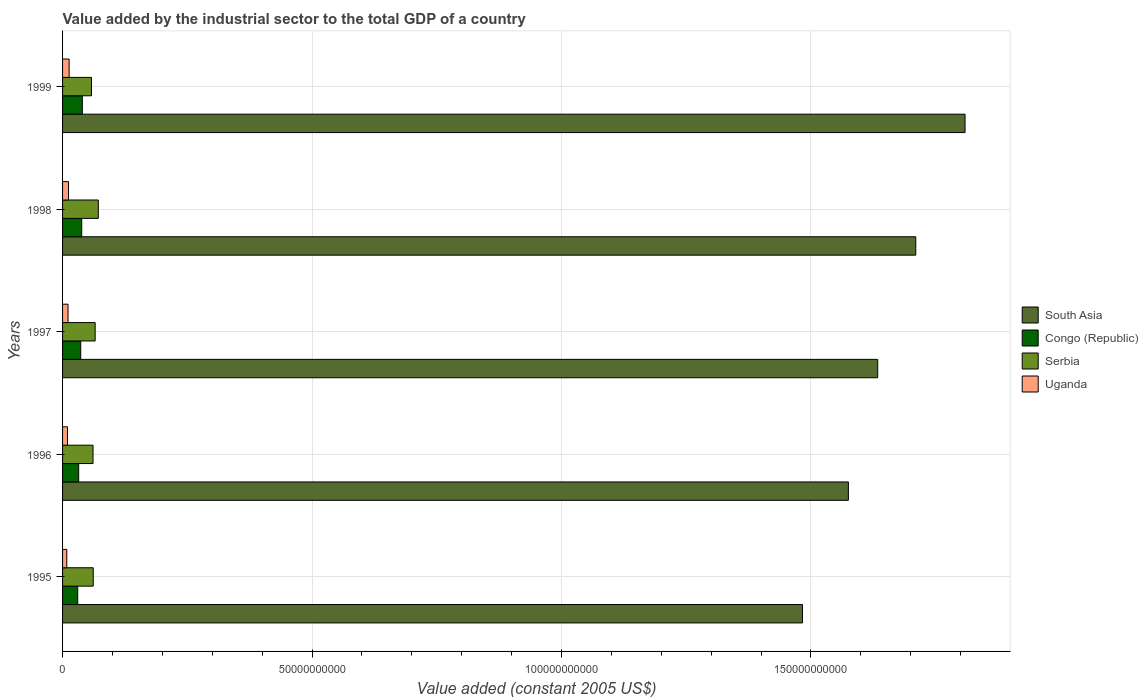How many groups of bars are there?
Give a very brief answer. 5. Are the number of bars per tick equal to the number of legend labels?
Your response must be concise. Yes. Are the number of bars on each tick of the Y-axis equal?
Make the answer very short. Yes. How many bars are there on the 4th tick from the top?
Your response must be concise. 4. How many bars are there on the 4th tick from the bottom?
Provide a short and direct response. 4. What is the label of the 3rd group of bars from the top?
Your response must be concise. 1997. In how many cases, is the number of bars for a given year not equal to the number of legend labels?
Your answer should be compact. 0. What is the value added by the industrial sector in Uganda in 1999?
Ensure brevity in your answer.  1.31e+09. Across all years, what is the maximum value added by the industrial sector in South Asia?
Your answer should be compact. 1.81e+11. Across all years, what is the minimum value added by the industrial sector in Serbia?
Your response must be concise. 5.79e+09. In which year was the value added by the industrial sector in Congo (Republic) minimum?
Make the answer very short. 1995. What is the total value added by the industrial sector in Congo (Republic) in the graph?
Make the answer very short. 1.77e+1. What is the difference between the value added by the industrial sector in South Asia in 1997 and that in 1999?
Provide a succinct answer. -1.75e+1. What is the difference between the value added by the industrial sector in Serbia in 1996 and the value added by the industrial sector in Congo (Republic) in 1999?
Keep it short and to the point. 2.14e+09. What is the average value added by the industrial sector in South Asia per year?
Make the answer very short. 1.64e+11. In the year 1999, what is the difference between the value added by the industrial sector in Uganda and value added by the industrial sector in South Asia?
Offer a very short reply. -1.80e+11. What is the ratio of the value added by the industrial sector in Serbia in 1995 to that in 1997?
Give a very brief answer. 0.94. Is the value added by the industrial sector in South Asia in 1998 less than that in 1999?
Keep it short and to the point. Yes. What is the difference between the highest and the second highest value added by the industrial sector in Serbia?
Your answer should be compact. 6.33e+08. What is the difference between the highest and the lowest value added by the industrial sector in Congo (Republic)?
Ensure brevity in your answer.  9.24e+08. In how many years, is the value added by the industrial sector in Serbia greater than the average value added by the industrial sector in Serbia taken over all years?
Keep it short and to the point. 2. What does the 3rd bar from the top in 1995 represents?
Give a very brief answer. Congo (Republic). What does the 4th bar from the bottom in 1997 represents?
Your response must be concise. Uganda. Is it the case that in every year, the sum of the value added by the industrial sector in South Asia and value added by the industrial sector in Serbia is greater than the value added by the industrial sector in Uganda?
Give a very brief answer. Yes. What is the difference between two consecutive major ticks on the X-axis?
Provide a short and direct response. 5.00e+1. Does the graph contain any zero values?
Provide a short and direct response. No. Does the graph contain grids?
Offer a very short reply. Yes. How are the legend labels stacked?
Keep it short and to the point. Vertical. What is the title of the graph?
Make the answer very short. Value added by the industrial sector to the total GDP of a country. Does "Cameroon" appear as one of the legend labels in the graph?
Your response must be concise. No. What is the label or title of the X-axis?
Provide a succinct answer. Value added (constant 2005 US$). What is the label or title of the Y-axis?
Give a very brief answer. Years. What is the Value added (constant 2005 US$) in South Asia in 1995?
Your answer should be compact. 1.48e+11. What is the Value added (constant 2005 US$) of Congo (Republic) in 1995?
Keep it short and to the point. 3.04e+09. What is the Value added (constant 2005 US$) in Serbia in 1995?
Ensure brevity in your answer.  6.15e+09. What is the Value added (constant 2005 US$) of Uganda in 1995?
Your answer should be very brief. 8.44e+08. What is the Value added (constant 2005 US$) in South Asia in 1996?
Offer a very short reply. 1.57e+11. What is the Value added (constant 2005 US$) of Congo (Republic) in 1996?
Provide a short and direct response. 3.23e+09. What is the Value added (constant 2005 US$) of Serbia in 1996?
Make the answer very short. 6.10e+09. What is the Value added (constant 2005 US$) in Uganda in 1996?
Provide a succinct answer. 9.84e+08. What is the Value added (constant 2005 US$) in South Asia in 1997?
Your response must be concise. 1.63e+11. What is the Value added (constant 2005 US$) of Congo (Republic) in 1997?
Your answer should be compact. 3.63e+09. What is the Value added (constant 2005 US$) in Serbia in 1997?
Give a very brief answer. 6.53e+09. What is the Value added (constant 2005 US$) in Uganda in 1997?
Provide a succinct answer. 1.10e+09. What is the Value added (constant 2005 US$) in South Asia in 1998?
Make the answer very short. 1.71e+11. What is the Value added (constant 2005 US$) of Congo (Republic) in 1998?
Offer a very short reply. 3.84e+09. What is the Value added (constant 2005 US$) in Serbia in 1998?
Your answer should be compact. 7.16e+09. What is the Value added (constant 2005 US$) in Uganda in 1998?
Offer a terse response. 1.19e+09. What is the Value added (constant 2005 US$) in South Asia in 1999?
Offer a terse response. 1.81e+11. What is the Value added (constant 2005 US$) of Congo (Republic) in 1999?
Your answer should be very brief. 3.96e+09. What is the Value added (constant 2005 US$) of Serbia in 1999?
Your response must be concise. 5.79e+09. What is the Value added (constant 2005 US$) in Uganda in 1999?
Offer a terse response. 1.31e+09. Across all years, what is the maximum Value added (constant 2005 US$) of South Asia?
Offer a terse response. 1.81e+11. Across all years, what is the maximum Value added (constant 2005 US$) of Congo (Republic)?
Provide a short and direct response. 3.96e+09. Across all years, what is the maximum Value added (constant 2005 US$) in Serbia?
Ensure brevity in your answer.  7.16e+09. Across all years, what is the maximum Value added (constant 2005 US$) of Uganda?
Your answer should be compact. 1.31e+09. Across all years, what is the minimum Value added (constant 2005 US$) of South Asia?
Make the answer very short. 1.48e+11. Across all years, what is the minimum Value added (constant 2005 US$) of Congo (Republic)?
Your response must be concise. 3.04e+09. Across all years, what is the minimum Value added (constant 2005 US$) of Serbia?
Provide a succinct answer. 5.79e+09. Across all years, what is the minimum Value added (constant 2005 US$) of Uganda?
Ensure brevity in your answer.  8.44e+08. What is the total Value added (constant 2005 US$) of South Asia in the graph?
Ensure brevity in your answer.  8.21e+11. What is the total Value added (constant 2005 US$) of Congo (Republic) in the graph?
Offer a very short reply. 1.77e+1. What is the total Value added (constant 2005 US$) of Serbia in the graph?
Offer a terse response. 3.17e+1. What is the total Value added (constant 2005 US$) of Uganda in the graph?
Offer a very short reply. 5.43e+09. What is the difference between the Value added (constant 2005 US$) in South Asia in 1995 and that in 1996?
Your answer should be compact. -9.20e+09. What is the difference between the Value added (constant 2005 US$) of Congo (Republic) in 1995 and that in 1996?
Offer a very short reply. -1.95e+08. What is the difference between the Value added (constant 2005 US$) of Serbia in 1995 and that in 1996?
Give a very brief answer. 4.23e+07. What is the difference between the Value added (constant 2005 US$) in Uganda in 1995 and that in 1996?
Your answer should be very brief. -1.40e+08. What is the difference between the Value added (constant 2005 US$) in South Asia in 1995 and that in 1997?
Ensure brevity in your answer.  -1.51e+1. What is the difference between the Value added (constant 2005 US$) of Congo (Republic) in 1995 and that in 1997?
Your answer should be compact. -5.97e+08. What is the difference between the Value added (constant 2005 US$) in Serbia in 1995 and that in 1997?
Keep it short and to the point. -3.85e+08. What is the difference between the Value added (constant 2005 US$) of Uganda in 1995 and that in 1997?
Your answer should be compact. -2.52e+08. What is the difference between the Value added (constant 2005 US$) in South Asia in 1995 and that in 1998?
Keep it short and to the point. -2.27e+1. What is the difference between the Value added (constant 2005 US$) in Congo (Republic) in 1995 and that in 1998?
Give a very brief answer. -8.02e+08. What is the difference between the Value added (constant 2005 US$) in Serbia in 1995 and that in 1998?
Ensure brevity in your answer.  -1.02e+09. What is the difference between the Value added (constant 2005 US$) of Uganda in 1995 and that in 1998?
Ensure brevity in your answer.  -3.47e+08. What is the difference between the Value added (constant 2005 US$) in South Asia in 1995 and that in 1999?
Make the answer very short. -3.26e+1. What is the difference between the Value added (constant 2005 US$) in Congo (Republic) in 1995 and that in 1999?
Offer a very short reply. -9.24e+08. What is the difference between the Value added (constant 2005 US$) of Serbia in 1995 and that in 1999?
Your response must be concise. 3.54e+08. What is the difference between the Value added (constant 2005 US$) in Uganda in 1995 and that in 1999?
Offer a very short reply. -4.71e+08. What is the difference between the Value added (constant 2005 US$) in South Asia in 1996 and that in 1997?
Offer a terse response. -5.88e+09. What is the difference between the Value added (constant 2005 US$) of Congo (Republic) in 1996 and that in 1997?
Your answer should be very brief. -4.02e+08. What is the difference between the Value added (constant 2005 US$) in Serbia in 1996 and that in 1997?
Keep it short and to the point. -4.27e+08. What is the difference between the Value added (constant 2005 US$) in Uganda in 1996 and that in 1997?
Your response must be concise. -1.12e+08. What is the difference between the Value added (constant 2005 US$) in South Asia in 1996 and that in 1998?
Give a very brief answer. -1.35e+1. What is the difference between the Value added (constant 2005 US$) in Congo (Republic) in 1996 and that in 1998?
Provide a succinct answer. -6.07e+08. What is the difference between the Value added (constant 2005 US$) of Serbia in 1996 and that in 1998?
Provide a short and direct response. -1.06e+09. What is the difference between the Value added (constant 2005 US$) in Uganda in 1996 and that in 1998?
Offer a terse response. -2.07e+08. What is the difference between the Value added (constant 2005 US$) in South Asia in 1996 and that in 1999?
Give a very brief answer. -2.34e+1. What is the difference between the Value added (constant 2005 US$) in Congo (Republic) in 1996 and that in 1999?
Ensure brevity in your answer.  -7.29e+08. What is the difference between the Value added (constant 2005 US$) in Serbia in 1996 and that in 1999?
Give a very brief answer. 3.12e+08. What is the difference between the Value added (constant 2005 US$) in Uganda in 1996 and that in 1999?
Provide a short and direct response. -3.31e+08. What is the difference between the Value added (constant 2005 US$) in South Asia in 1997 and that in 1998?
Offer a very short reply. -7.63e+09. What is the difference between the Value added (constant 2005 US$) of Congo (Republic) in 1997 and that in 1998?
Keep it short and to the point. -2.05e+08. What is the difference between the Value added (constant 2005 US$) in Serbia in 1997 and that in 1998?
Provide a succinct answer. -6.33e+08. What is the difference between the Value added (constant 2005 US$) of Uganda in 1997 and that in 1998?
Make the answer very short. -9.55e+07. What is the difference between the Value added (constant 2005 US$) of South Asia in 1997 and that in 1999?
Provide a succinct answer. -1.75e+1. What is the difference between the Value added (constant 2005 US$) of Congo (Republic) in 1997 and that in 1999?
Ensure brevity in your answer.  -3.26e+08. What is the difference between the Value added (constant 2005 US$) of Serbia in 1997 and that in 1999?
Your answer should be compact. 7.39e+08. What is the difference between the Value added (constant 2005 US$) in Uganda in 1997 and that in 1999?
Your answer should be compact. -2.19e+08. What is the difference between the Value added (constant 2005 US$) of South Asia in 1998 and that in 1999?
Offer a very short reply. -9.88e+09. What is the difference between the Value added (constant 2005 US$) in Congo (Republic) in 1998 and that in 1999?
Your response must be concise. -1.21e+08. What is the difference between the Value added (constant 2005 US$) of Serbia in 1998 and that in 1999?
Your response must be concise. 1.37e+09. What is the difference between the Value added (constant 2005 US$) in Uganda in 1998 and that in 1999?
Offer a very short reply. -1.24e+08. What is the difference between the Value added (constant 2005 US$) of South Asia in 1995 and the Value added (constant 2005 US$) of Congo (Republic) in 1996?
Provide a short and direct response. 1.45e+11. What is the difference between the Value added (constant 2005 US$) of South Asia in 1995 and the Value added (constant 2005 US$) of Serbia in 1996?
Ensure brevity in your answer.  1.42e+11. What is the difference between the Value added (constant 2005 US$) of South Asia in 1995 and the Value added (constant 2005 US$) of Uganda in 1996?
Provide a short and direct response. 1.47e+11. What is the difference between the Value added (constant 2005 US$) in Congo (Republic) in 1995 and the Value added (constant 2005 US$) in Serbia in 1996?
Make the answer very short. -3.07e+09. What is the difference between the Value added (constant 2005 US$) of Congo (Republic) in 1995 and the Value added (constant 2005 US$) of Uganda in 1996?
Ensure brevity in your answer.  2.05e+09. What is the difference between the Value added (constant 2005 US$) in Serbia in 1995 and the Value added (constant 2005 US$) in Uganda in 1996?
Provide a short and direct response. 5.16e+09. What is the difference between the Value added (constant 2005 US$) in South Asia in 1995 and the Value added (constant 2005 US$) in Congo (Republic) in 1997?
Provide a succinct answer. 1.45e+11. What is the difference between the Value added (constant 2005 US$) in South Asia in 1995 and the Value added (constant 2005 US$) in Serbia in 1997?
Provide a short and direct response. 1.42e+11. What is the difference between the Value added (constant 2005 US$) in South Asia in 1995 and the Value added (constant 2005 US$) in Uganda in 1997?
Your answer should be very brief. 1.47e+11. What is the difference between the Value added (constant 2005 US$) of Congo (Republic) in 1995 and the Value added (constant 2005 US$) of Serbia in 1997?
Provide a succinct answer. -3.50e+09. What is the difference between the Value added (constant 2005 US$) in Congo (Republic) in 1995 and the Value added (constant 2005 US$) in Uganda in 1997?
Keep it short and to the point. 1.94e+09. What is the difference between the Value added (constant 2005 US$) of Serbia in 1995 and the Value added (constant 2005 US$) of Uganda in 1997?
Your response must be concise. 5.05e+09. What is the difference between the Value added (constant 2005 US$) of South Asia in 1995 and the Value added (constant 2005 US$) of Congo (Republic) in 1998?
Keep it short and to the point. 1.44e+11. What is the difference between the Value added (constant 2005 US$) in South Asia in 1995 and the Value added (constant 2005 US$) in Serbia in 1998?
Offer a terse response. 1.41e+11. What is the difference between the Value added (constant 2005 US$) in South Asia in 1995 and the Value added (constant 2005 US$) in Uganda in 1998?
Your answer should be very brief. 1.47e+11. What is the difference between the Value added (constant 2005 US$) in Congo (Republic) in 1995 and the Value added (constant 2005 US$) in Serbia in 1998?
Provide a succinct answer. -4.13e+09. What is the difference between the Value added (constant 2005 US$) of Congo (Republic) in 1995 and the Value added (constant 2005 US$) of Uganda in 1998?
Give a very brief answer. 1.85e+09. What is the difference between the Value added (constant 2005 US$) of Serbia in 1995 and the Value added (constant 2005 US$) of Uganda in 1998?
Ensure brevity in your answer.  4.96e+09. What is the difference between the Value added (constant 2005 US$) in South Asia in 1995 and the Value added (constant 2005 US$) in Congo (Republic) in 1999?
Offer a terse response. 1.44e+11. What is the difference between the Value added (constant 2005 US$) in South Asia in 1995 and the Value added (constant 2005 US$) in Serbia in 1999?
Provide a short and direct response. 1.43e+11. What is the difference between the Value added (constant 2005 US$) of South Asia in 1995 and the Value added (constant 2005 US$) of Uganda in 1999?
Your answer should be very brief. 1.47e+11. What is the difference between the Value added (constant 2005 US$) in Congo (Republic) in 1995 and the Value added (constant 2005 US$) in Serbia in 1999?
Your response must be concise. -2.76e+09. What is the difference between the Value added (constant 2005 US$) of Congo (Republic) in 1995 and the Value added (constant 2005 US$) of Uganda in 1999?
Offer a terse response. 1.72e+09. What is the difference between the Value added (constant 2005 US$) of Serbia in 1995 and the Value added (constant 2005 US$) of Uganda in 1999?
Offer a very short reply. 4.83e+09. What is the difference between the Value added (constant 2005 US$) in South Asia in 1996 and the Value added (constant 2005 US$) in Congo (Republic) in 1997?
Your answer should be compact. 1.54e+11. What is the difference between the Value added (constant 2005 US$) of South Asia in 1996 and the Value added (constant 2005 US$) of Serbia in 1997?
Ensure brevity in your answer.  1.51e+11. What is the difference between the Value added (constant 2005 US$) of South Asia in 1996 and the Value added (constant 2005 US$) of Uganda in 1997?
Provide a succinct answer. 1.56e+11. What is the difference between the Value added (constant 2005 US$) in Congo (Republic) in 1996 and the Value added (constant 2005 US$) in Serbia in 1997?
Your answer should be compact. -3.30e+09. What is the difference between the Value added (constant 2005 US$) of Congo (Republic) in 1996 and the Value added (constant 2005 US$) of Uganda in 1997?
Your answer should be compact. 2.14e+09. What is the difference between the Value added (constant 2005 US$) of Serbia in 1996 and the Value added (constant 2005 US$) of Uganda in 1997?
Your answer should be very brief. 5.01e+09. What is the difference between the Value added (constant 2005 US$) in South Asia in 1996 and the Value added (constant 2005 US$) in Congo (Republic) in 1998?
Provide a short and direct response. 1.54e+11. What is the difference between the Value added (constant 2005 US$) of South Asia in 1996 and the Value added (constant 2005 US$) of Serbia in 1998?
Your answer should be very brief. 1.50e+11. What is the difference between the Value added (constant 2005 US$) of South Asia in 1996 and the Value added (constant 2005 US$) of Uganda in 1998?
Make the answer very short. 1.56e+11. What is the difference between the Value added (constant 2005 US$) in Congo (Republic) in 1996 and the Value added (constant 2005 US$) in Serbia in 1998?
Give a very brief answer. -3.93e+09. What is the difference between the Value added (constant 2005 US$) of Congo (Republic) in 1996 and the Value added (constant 2005 US$) of Uganda in 1998?
Provide a succinct answer. 2.04e+09. What is the difference between the Value added (constant 2005 US$) in Serbia in 1996 and the Value added (constant 2005 US$) in Uganda in 1998?
Make the answer very short. 4.91e+09. What is the difference between the Value added (constant 2005 US$) of South Asia in 1996 and the Value added (constant 2005 US$) of Congo (Republic) in 1999?
Offer a very short reply. 1.54e+11. What is the difference between the Value added (constant 2005 US$) of South Asia in 1996 and the Value added (constant 2005 US$) of Serbia in 1999?
Give a very brief answer. 1.52e+11. What is the difference between the Value added (constant 2005 US$) in South Asia in 1996 and the Value added (constant 2005 US$) in Uganda in 1999?
Your response must be concise. 1.56e+11. What is the difference between the Value added (constant 2005 US$) in Congo (Republic) in 1996 and the Value added (constant 2005 US$) in Serbia in 1999?
Give a very brief answer. -2.56e+09. What is the difference between the Value added (constant 2005 US$) of Congo (Republic) in 1996 and the Value added (constant 2005 US$) of Uganda in 1999?
Offer a very short reply. 1.92e+09. What is the difference between the Value added (constant 2005 US$) in Serbia in 1996 and the Value added (constant 2005 US$) in Uganda in 1999?
Offer a terse response. 4.79e+09. What is the difference between the Value added (constant 2005 US$) in South Asia in 1997 and the Value added (constant 2005 US$) in Congo (Republic) in 1998?
Make the answer very short. 1.60e+11. What is the difference between the Value added (constant 2005 US$) in South Asia in 1997 and the Value added (constant 2005 US$) in Serbia in 1998?
Your answer should be compact. 1.56e+11. What is the difference between the Value added (constant 2005 US$) in South Asia in 1997 and the Value added (constant 2005 US$) in Uganda in 1998?
Keep it short and to the point. 1.62e+11. What is the difference between the Value added (constant 2005 US$) in Congo (Republic) in 1997 and the Value added (constant 2005 US$) in Serbia in 1998?
Your response must be concise. -3.53e+09. What is the difference between the Value added (constant 2005 US$) of Congo (Republic) in 1997 and the Value added (constant 2005 US$) of Uganda in 1998?
Your answer should be compact. 2.44e+09. What is the difference between the Value added (constant 2005 US$) in Serbia in 1997 and the Value added (constant 2005 US$) in Uganda in 1998?
Ensure brevity in your answer.  5.34e+09. What is the difference between the Value added (constant 2005 US$) in South Asia in 1997 and the Value added (constant 2005 US$) in Congo (Republic) in 1999?
Keep it short and to the point. 1.59e+11. What is the difference between the Value added (constant 2005 US$) of South Asia in 1997 and the Value added (constant 2005 US$) of Serbia in 1999?
Ensure brevity in your answer.  1.58e+11. What is the difference between the Value added (constant 2005 US$) of South Asia in 1997 and the Value added (constant 2005 US$) of Uganda in 1999?
Your answer should be compact. 1.62e+11. What is the difference between the Value added (constant 2005 US$) of Congo (Republic) in 1997 and the Value added (constant 2005 US$) of Serbia in 1999?
Provide a succinct answer. -2.16e+09. What is the difference between the Value added (constant 2005 US$) in Congo (Republic) in 1997 and the Value added (constant 2005 US$) in Uganda in 1999?
Give a very brief answer. 2.32e+09. What is the difference between the Value added (constant 2005 US$) of Serbia in 1997 and the Value added (constant 2005 US$) of Uganda in 1999?
Ensure brevity in your answer.  5.22e+09. What is the difference between the Value added (constant 2005 US$) of South Asia in 1998 and the Value added (constant 2005 US$) of Congo (Republic) in 1999?
Ensure brevity in your answer.  1.67e+11. What is the difference between the Value added (constant 2005 US$) in South Asia in 1998 and the Value added (constant 2005 US$) in Serbia in 1999?
Ensure brevity in your answer.  1.65e+11. What is the difference between the Value added (constant 2005 US$) in South Asia in 1998 and the Value added (constant 2005 US$) in Uganda in 1999?
Ensure brevity in your answer.  1.70e+11. What is the difference between the Value added (constant 2005 US$) of Congo (Republic) in 1998 and the Value added (constant 2005 US$) of Serbia in 1999?
Ensure brevity in your answer.  -1.95e+09. What is the difference between the Value added (constant 2005 US$) in Congo (Republic) in 1998 and the Value added (constant 2005 US$) in Uganda in 1999?
Your response must be concise. 2.52e+09. What is the difference between the Value added (constant 2005 US$) of Serbia in 1998 and the Value added (constant 2005 US$) of Uganda in 1999?
Give a very brief answer. 5.85e+09. What is the average Value added (constant 2005 US$) of South Asia per year?
Make the answer very short. 1.64e+11. What is the average Value added (constant 2005 US$) in Congo (Republic) per year?
Provide a succinct answer. 3.54e+09. What is the average Value added (constant 2005 US$) of Serbia per year?
Your answer should be very brief. 6.35e+09. What is the average Value added (constant 2005 US$) in Uganda per year?
Your answer should be compact. 1.09e+09. In the year 1995, what is the difference between the Value added (constant 2005 US$) in South Asia and Value added (constant 2005 US$) in Congo (Republic)?
Ensure brevity in your answer.  1.45e+11. In the year 1995, what is the difference between the Value added (constant 2005 US$) in South Asia and Value added (constant 2005 US$) in Serbia?
Provide a succinct answer. 1.42e+11. In the year 1995, what is the difference between the Value added (constant 2005 US$) of South Asia and Value added (constant 2005 US$) of Uganda?
Provide a short and direct response. 1.47e+11. In the year 1995, what is the difference between the Value added (constant 2005 US$) of Congo (Republic) and Value added (constant 2005 US$) of Serbia?
Your response must be concise. -3.11e+09. In the year 1995, what is the difference between the Value added (constant 2005 US$) in Congo (Republic) and Value added (constant 2005 US$) in Uganda?
Keep it short and to the point. 2.19e+09. In the year 1995, what is the difference between the Value added (constant 2005 US$) of Serbia and Value added (constant 2005 US$) of Uganda?
Make the answer very short. 5.30e+09. In the year 1996, what is the difference between the Value added (constant 2005 US$) in South Asia and Value added (constant 2005 US$) in Congo (Republic)?
Offer a very short reply. 1.54e+11. In the year 1996, what is the difference between the Value added (constant 2005 US$) of South Asia and Value added (constant 2005 US$) of Serbia?
Keep it short and to the point. 1.51e+11. In the year 1996, what is the difference between the Value added (constant 2005 US$) in South Asia and Value added (constant 2005 US$) in Uganda?
Provide a succinct answer. 1.57e+11. In the year 1996, what is the difference between the Value added (constant 2005 US$) of Congo (Republic) and Value added (constant 2005 US$) of Serbia?
Your answer should be compact. -2.87e+09. In the year 1996, what is the difference between the Value added (constant 2005 US$) of Congo (Republic) and Value added (constant 2005 US$) of Uganda?
Make the answer very short. 2.25e+09. In the year 1996, what is the difference between the Value added (constant 2005 US$) in Serbia and Value added (constant 2005 US$) in Uganda?
Keep it short and to the point. 5.12e+09. In the year 1997, what is the difference between the Value added (constant 2005 US$) in South Asia and Value added (constant 2005 US$) in Congo (Republic)?
Keep it short and to the point. 1.60e+11. In the year 1997, what is the difference between the Value added (constant 2005 US$) of South Asia and Value added (constant 2005 US$) of Serbia?
Offer a terse response. 1.57e+11. In the year 1997, what is the difference between the Value added (constant 2005 US$) of South Asia and Value added (constant 2005 US$) of Uganda?
Ensure brevity in your answer.  1.62e+11. In the year 1997, what is the difference between the Value added (constant 2005 US$) of Congo (Republic) and Value added (constant 2005 US$) of Serbia?
Offer a terse response. -2.90e+09. In the year 1997, what is the difference between the Value added (constant 2005 US$) of Congo (Republic) and Value added (constant 2005 US$) of Uganda?
Offer a very short reply. 2.54e+09. In the year 1997, what is the difference between the Value added (constant 2005 US$) in Serbia and Value added (constant 2005 US$) in Uganda?
Offer a very short reply. 5.44e+09. In the year 1998, what is the difference between the Value added (constant 2005 US$) of South Asia and Value added (constant 2005 US$) of Congo (Republic)?
Your answer should be very brief. 1.67e+11. In the year 1998, what is the difference between the Value added (constant 2005 US$) of South Asia and Value added (constant 2005 US$) of Serbia?
Your answer should be compact. 1.64e+11. In the year 1998, what is the difference between the Value added (constant 2005 US$) of South Asia and Value added (constant 2005 US$) of Uganda?
Offer a very short reply. 1.70e+11. In the year 1998, what is the difference between the Value added (constant 2005 US$) in Congo (Republic) and Value added (constant 2005 US$) in Serbia?
Offer a very short reply. -3.33e+09. In the year 1998, what is the difference between the Value added (constant 2005 US$) of Congo (Republic) and Value added (constant 2005 US$) of Uganda?
Make the answer very short. 2.65e+09. In the year 1998, what is the difference between the Value added (constant 2005 US$) of Serbia and Value added (constant 2005 US$) of Uganda?
Make the answer very short. 5.97e+09. In the year 1999, what is the difference between the Value added (constant 2005 US$) in South Asia and Value added (constant 2005 US$) in Congo (Republic)?
Provide a short and direct response. 1.77e+11. In the year 1999, what is the difference between the Value added (constant 2005 US$) in South Asia and Value added (constant 2005 US$) in Serbia?
Give a very brief answer. 1.75e+11. In the year 1999, what is the difference between the Value added (constant 2005 US$) in South Asia and Value added (constant 2005 US$) in Uganda?
Ensure brevity in your answer.  1.80e+11. In the year 1999, what is the difference between the Value added (constant 2005 US$) of Congo (Republic) and Value added (constant 2005 US$) of Serbia?
Give a very brief answer. -1.83e+09. In the year 1999, what is the difference between the Value added (constant 2005 US$) in Congo (Republic) and Value added (constant 2005 US$) in Uganda?
Ensure brevity in your answer.  2.65e+09. In the year 1999, what is the difference between the Value added (constant 2005 US$) in Serbia and Value added (constant 2005 US$) in Uganda?
Your answer should be very brief. 4.48e+09. What is the ratio of the Value added (constant 2005 US$) in South Asia in 1995 to that in 1996?
Your answer should be very brief. 0.94. What is the ratio of the Value added (constant 2005 US$) of Congo (Republic) in 1995 to that in 1996?
Keep it short and to the point. 0.94. What is the ratio of the Value added (constant 2005 US$) in Uganda in 1995 to that in 1996?
Your response must be concise. 0.86. What is the ratio of the Value added (constant 2005 US$) of South Asia in 1995 to that in 1997?
Give a very brief answer. 0.91. What is the ratio of the Value added (constant 2005 US$) of Congo (Republic) in 1995 to that in 1997?
Give a very brief answer. 0.84. What is the ratio of the Value added (constant 2005 US$) of Serbia in 1995 to that in 1997?
Your answer should be very brief. 0.94. What is the ratio of the Value added (constant 2005 US$) of Uganda in 1995 to that in 1997?
Offer a terse response. 0.77. What is the ratio of the Value added (constant 2005 US$) of South Asia in 1995 to that in 1998?
Offer a terse response. 0.87. What is the ratio of the Value added (constant 2005 US$) in Congo (Republic) in 1995 to that in 1998?
Give a very brief answer. 0.79. What is the ratio of the Value added (constant 2005 US$) of Serbia in 1995 to that in 1998?
Your answer should be very brief. 0.86. What is the ratio of the Value added (constant 2005 US$) in Uganda in 1995 to that in 1998?
Your answer should be very brief. 0.71. What is the ratio of the Value added (constant 2005 US$) of South Asia in 1995 to that in 1999?
Provide a short and direct response. 0.82. What is the ratio of the Value added (constant 2005 US$) in Congo (Republic) in 1995 to that in 1999?
Your answer should be compact. 0.77. What is the ratio of the Value added (constant 2005 US$) in Serbia in 1995 to that in 1999?
Offer a terse response. 1.06. What is the ratio of the Value added (constant 2005 US$) in Uganda in 1995 to that in 1999?
Provide a succinct answer. 0.64. What is the ratio of the Value added (constant 2005 US$) in Congo (Republic) in 1996 to that in 1997?
Ensure brevity in your answer.  0.89. What is the ratio of the Value added (constant 2005 US$) in Serbia in 1996 to that in 1997?
Ensure brevity in your answer.  0.93. What is the ratio of the Value added (constant 2005 US$) of Uganda in 1996 to that in 1997?
Offer a terse response. 0.9. What is the ratio of the Value added (constant 2005 US$) in South Asia in 1996 to that in 1998?
Your response must be concise. 0.92. What is the ratio of the Value added (constant 2005 US$) of Congo (Republic) in 1996 to that in 1998?
Ensure brevity in your answer.  0.84. What is the ratio of the Value added (constant 2005 US$) in Serbia in 1996 to that in 1998?
Offer a terse response. 0.85. What is the ratio of the Value added (constant 2005 US$) in Uganda in 1996 to that in 1998?
Your answer should be very brief. 0.83. What is the ratio of the Value added (constant 2005 US$) in South Asia in 1996 to that in 1999?
Your response must be concise. 0.87. What is the ratio of the Value added (constant 2005 US$) in Congo (Republic) in 1996 to that in 1999?
Provide a short and direct response. 0.82. What is the ratio of the Value added (constant 2005 US$) of Serbia in 1996 to that in 1999?
Offer a terse response. 1.05. What is the ratio of the Value added (constant 2005 US$) of Uganda in 1996 to that in 1999?
Offer a terse response. 0.75. What is the ratio of the Value added (constant 2005 US$) in South Asia in 1997 to that in 1998?
Your answer should be very brief. 0.96. What is the ratio of the Value added (constant 2005 US$) in Congo (Republic) in 1997 to that in 1998?
Your answer should be compact. 0.95. What is the ratio of the Value added (constant 2005 US$) in Serbia in 1997 to that in 1998?
Give a very brief answer. 0.91. What is the ratio of the Value added (constant 2005 US$) of Uganda in 1997 to that in 1998?
Your answer should be very brief. 0.92. What is the ratio of the Value added (constant 2005 US$) in South Asia in 1997 to that in 1999?
Give a very brief answer. 0.9. What is the ratio of the Value added (constant 2005 US$) of Congo (Republic) in 1997 to that in 1999?
Provide a succinct answer. 0.92. What is the ratio of the Value added (constant 2005 US$) in Serbia in 1997 to that in 1999?
Offer a very short reply. 1.13. What is the ratio of the Value added (constant 2005 US$) in Uganda in 1997 to that in 1999?
Provide a short and direct response. 0.83. What is the ratio of the Value added (constant 2005 US$) in South Asia in 1998 to that in 1999?
Keep it short and to the point. 0.95. What is the ratio of the Value added (constant 2005 US$) in Congo (Republic) in 1998 to that in 1999?
Ensure brevity in your answer.  0.97. What is the ratio of the Value added (constant 2005 US$) of Serbia in 1998 to that in 1999?
Ensure brevity in your answer.  1.24. What is the ratio of the Value added (constant 2005 US$) of Uganda in 1998 to that in 1999?
Offer a very short reply. 0.91. What is the difference between the highest and the second highest Value added (constant 2005 US$) in South Asia?
Your answer should be very brief. 9.88e+09. What is the difference between the highest and the second highest Value added (constant 2005 US$) in Congo (Republic)?
Provide a short and direct response. 1.21e+08. What is the difference between the highest and the second highest Value added (constant 2005 US$) of Serbia?
Keep it short and to the point. 6.33e+08. What is the difference between the highest and the second highest Value added (constant 2005 US$) of Uganda?
Your answer should be very brief. 1.24e+08. What is the difference between the highest and the lowest Value added (constant 2005 US$) of South Asia?
Ensure brevity in your answer.  3.26e+1. What is the difference between the highest and the lowest Value added (constant 2005 US$) of Congo (Republic)?
Make the answer very short. 9.24e+08. What is the difference between the highest and the lowest Value added (constant 2005 US$) in Serbia?
Make the answer very short. 1.37e+09. What is the difference between the highest and the lowest Value added (constant 2005 US$) in Uganda?
Offer a very short reply. 4.71e+08. 